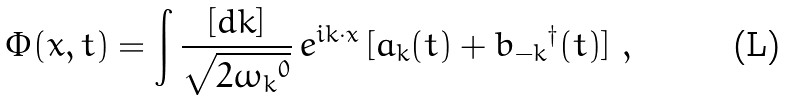<formula> <loc_0><loc_0><loc_500><loc_500>\Phi ( x , t ) = \int \frac { [ d { k } ] } { \sqrt { 2 { \omega _ { k } } ^ { 0 } } } \, e ^ { i { k } \cdot x } \, [ a _ { k } ( t ) + { b _ { - { k } } } ^ { \dagger } ( t ) ] \ ,</formula> 